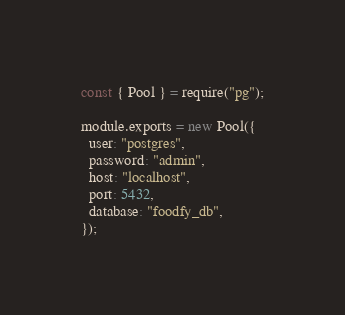Convert code to text. <code><loc_0><loc_0><loc_500><loc_500><_JavaScript_>const { Pool } = require("pg");

module.exports = new Pool({
  user: "postgres",
  password: "admin",
  host: "localhost",
  port: 5432,
  database: "foodfy_db",
});
</code> 